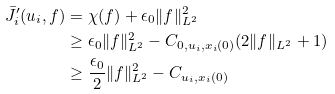<formula> <loc_0><loc_0><loc_500><loc_500>\bar { J } ^ { \prime } _ { i } ( u _ { i } , f ) & = \chi ( f ) + \epsilon _ { 0 } \| f \| ^ { 2 } _ { L ^ { 2 } } \\ & \geq { \epsilon _ { 0 } } \| f \| ^ { 2 } _ { L ^ { 2 } } - C _ { 0 , u _ { i } , x _ { i } ( 0 ) } ( 2 \| f \| _ { L ^ { 2 } } + 1 ) \\ & \geq \frac { \epsilon _ { 0 } } { 2 } \| f \| ^ { 2 } _ { L ^ { 2 } } - C _ { u _ { i } , x _ { i } ( 0 ) }</formula> 